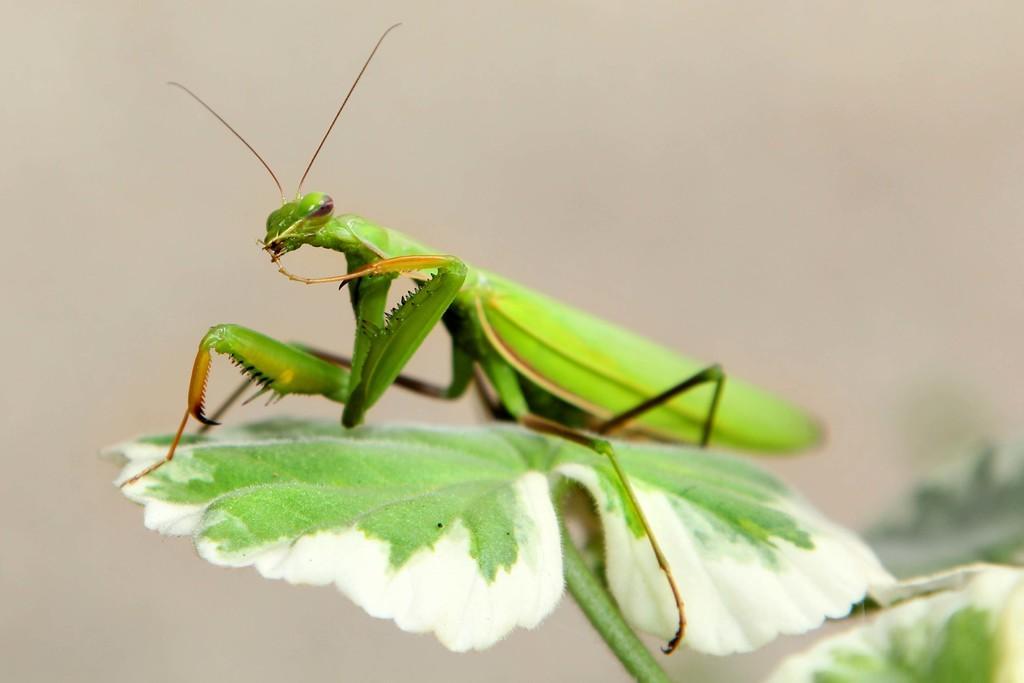Describe this image in one or two sentences. In this picture we can see an insect on the leaf. Behind the insect, there is the blurred background. 